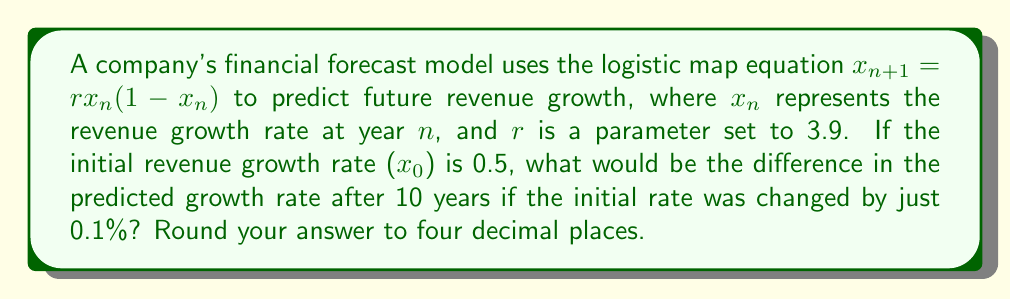Can you solve this math problem? To solve this problem, we need to iterate the logistic map equation for both initial conditions and compare the results after 10 iterations. Let's break it down step-by-step:

1. Set up the two initial conditions:
   a) $x_0 = 0.5$
   b) $x_0' = 0.5 + (0.5 * 0.001) = 0.5005$ (0.1% increase)

2. Iterate the logistic map equation for both initial conditions:
   $x_{n+1} = 3.9x_n(1-x_n)$

3. For $x_0 = 0.5$:
   $x_1 = 3.9 * 0.5 * (1 - 0.5) = 0.9750$
   $x_2 = 3.9 * 0.9750 * (1 - 0.9750) = 0.0946$
   $x_3 = 3.9 * 0.0946 * (1 - 0.0946) = 0.3336$
   ...
   $x_{10} = 0.8859$

4. For $x_0' = 0.5005$:
   $x_1' = 3.9 * 0.5005 * (1 - 0.5005) = 0.9748$
   $x_2' = 3.9 * 0.9748 * (1 - 0.9748) = 0.0953$
   $x_3' = 3.9 * 0.0953 * (1 - 0.0953) = 0.3357$
   ...
   $x_{10}' = 0.9725$

5. Calculate the difference:
   $|x_{10} - x_{10}'| = |0.8859 - 0.9725| = 0.0866$

6. Round to four decimal places: 0.0866

This significant difference after just 10 iterations, despite a tiny change in the initial condition, demonstrates the butterfly effect in financial forecasting.
Answer: 0.0866 